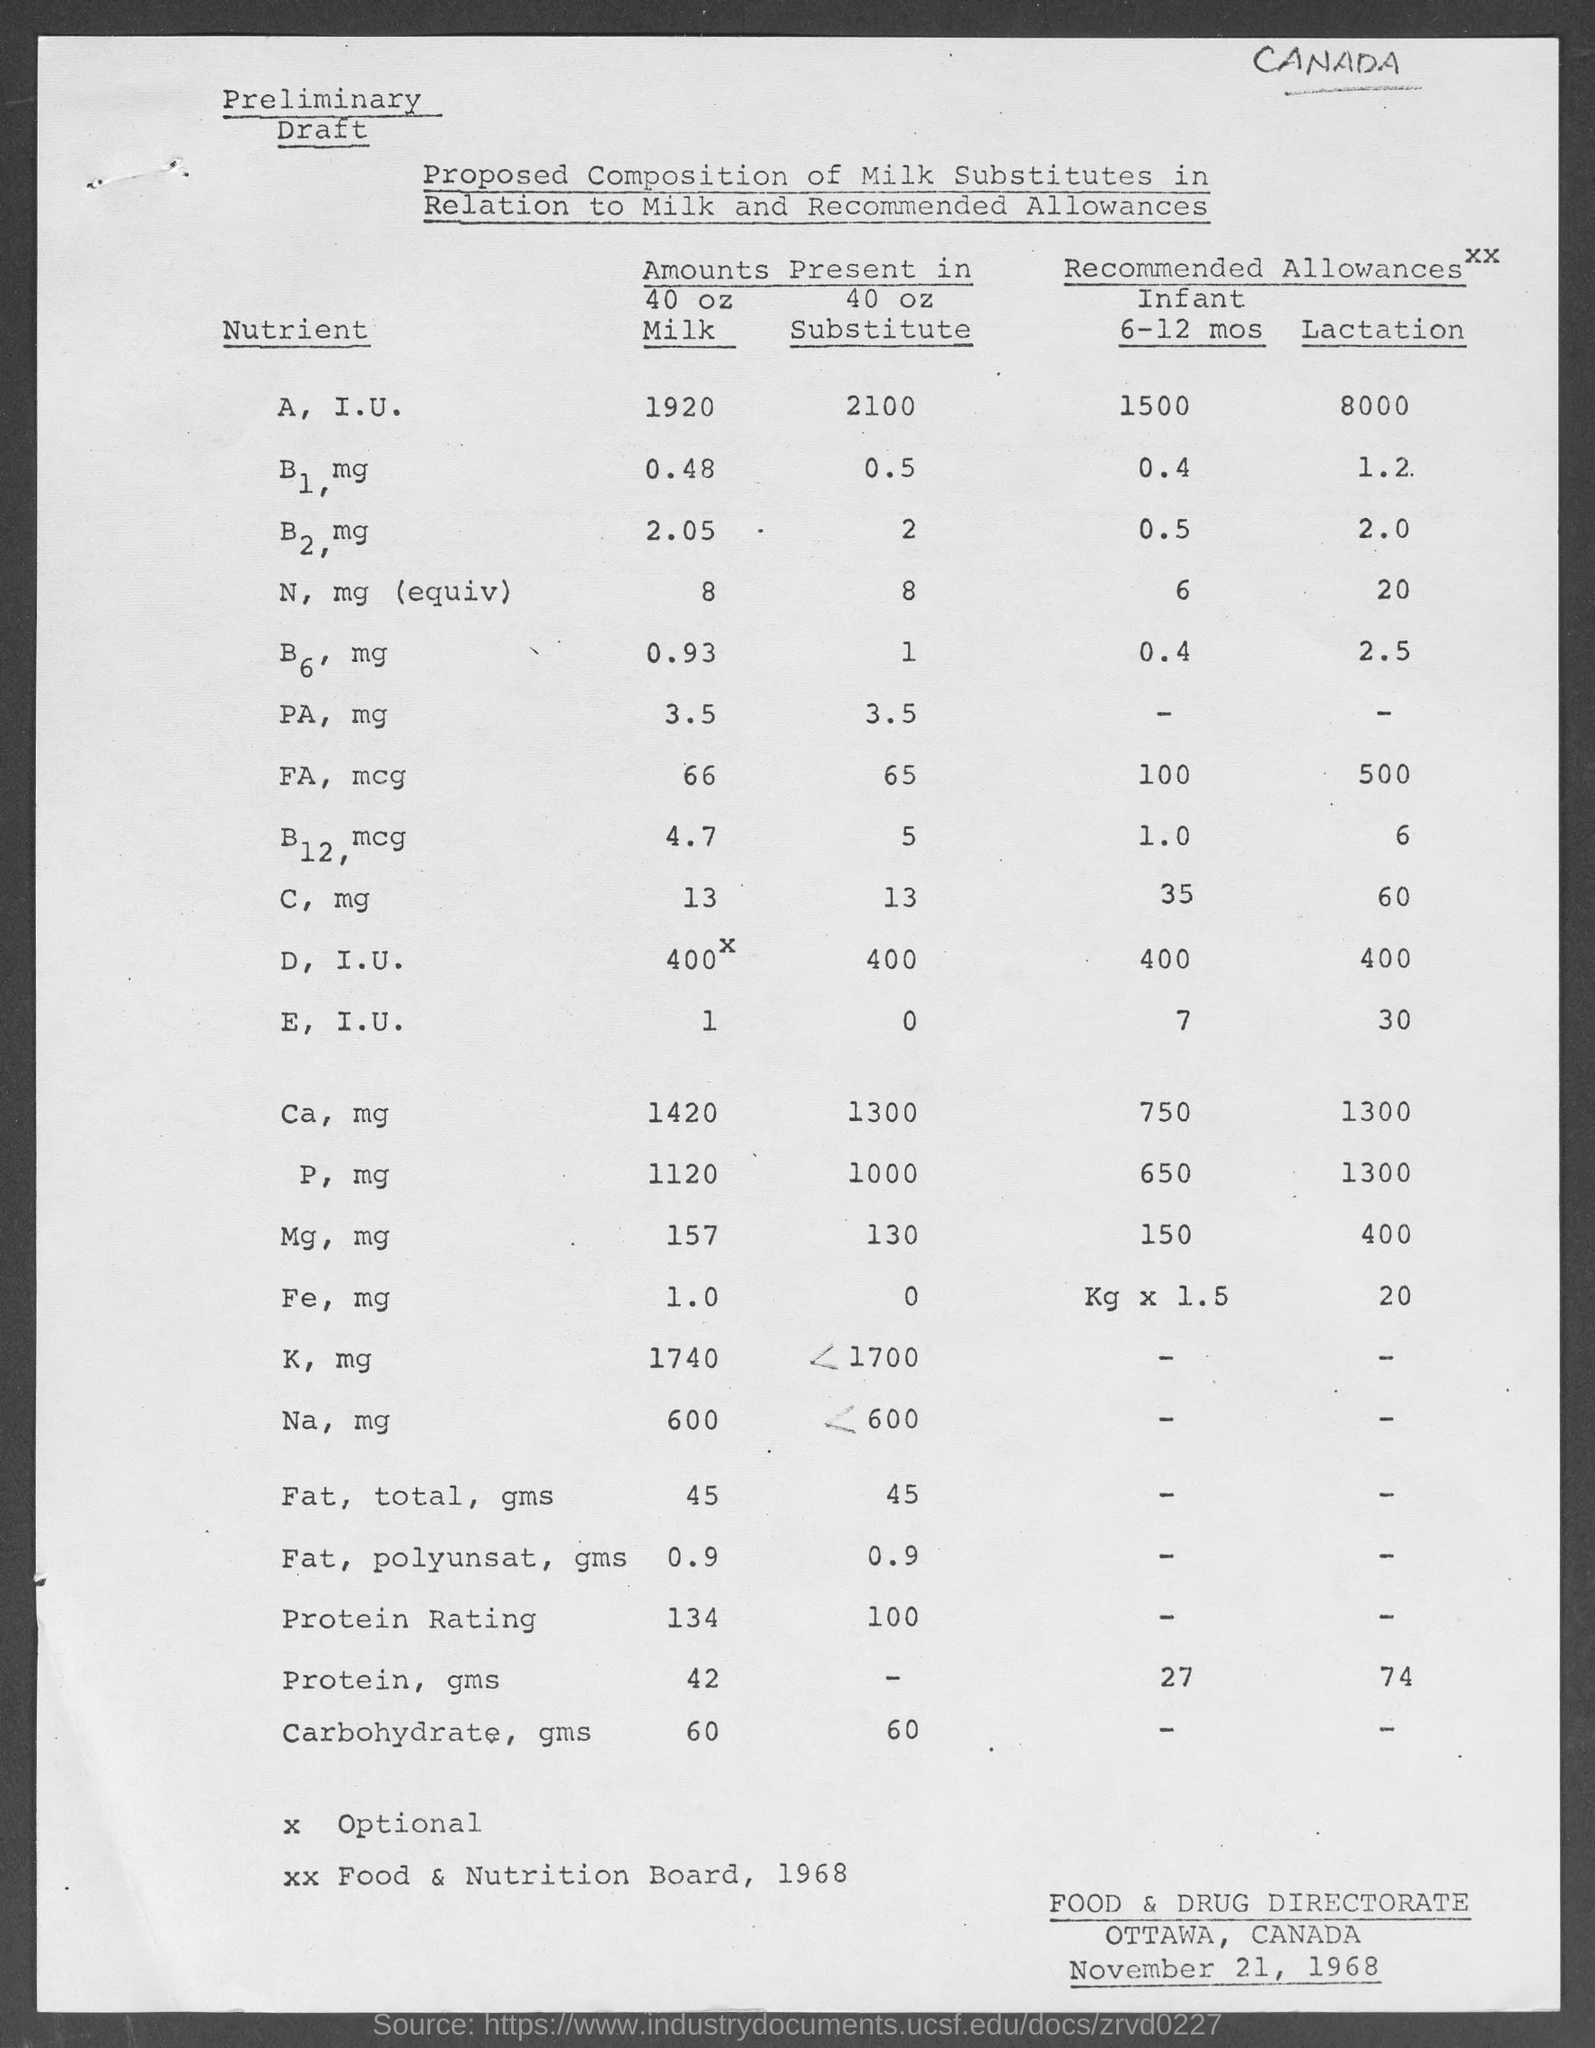How much amount of a, i.u. nutrients present in milk as mentioned in the given form ?
Make the answer very short. 1920. How much amount of  b1, mg , nutrients present in milk as mentioned in the given form ?
Your answer should be compact. 0.48. How much amount of b2 , mg nutrients present in milk as mentioned in the given form ?
Provide a succinct answer. 2.05. How much amount of c, mg nutrients present in milk as mentioned in the given form ?
Provide a succinct answer. 13. How much amount of b6, mg , nutrients present in milk as mentioned in the given form ?
Ensure brevity in your answer.  0.93. How much amount of a, i.u. nutrients present in substitute as mentioned in the given form ?
Your response must be concise. 2100. How much amount of b1, mg nutrients present in substitute as mentioned in the given form ?
Ensure brevity in your answer.  0.5. How much amount of b6, mg  nutrients present in substitute as mentioned in the given form ?
Your answer should be compact. 1. How much amount of  b12, mcg , nutrients present in milk as mentioned in the given form ?
Provide a succinct answer. 4.7. What is the date mentioned in the given form ?
Provide a short and direct response. November 21, 1968. 